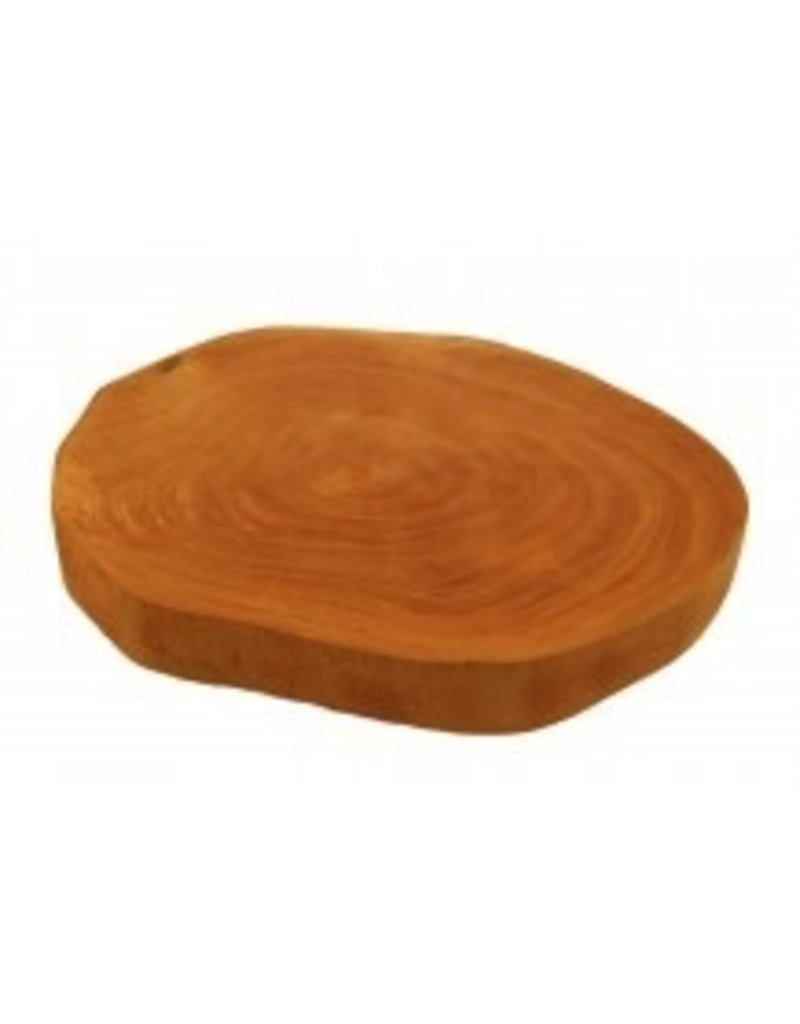Based on the growth rings visible on the wooden slab, what can be inferred about the environmental conditions during the life of the tree from which this slab was cut? Examining the growth rings on the wooden slab provides a visual chronicle of the tree's life. The thickness of each ring varies; wider bands typically indicate years of optimal growth conditions such as plentiful rainfall, favorable temperatures, and adequate nutrients, showcasing times of environmental abundance. Conversely, narrower rings point to periods of stress, possibly due to drought, excessive cold, or other unfavorable conditions. These patterns suggest that throughout its lifetime, the tree experienced a range of environmental fluctuations. To better understand the specific impacts on growth, additional analysis involving dendrochronology or a study of the local climate history could reveal more detailed insights into the environmental challenges the tree faced. 